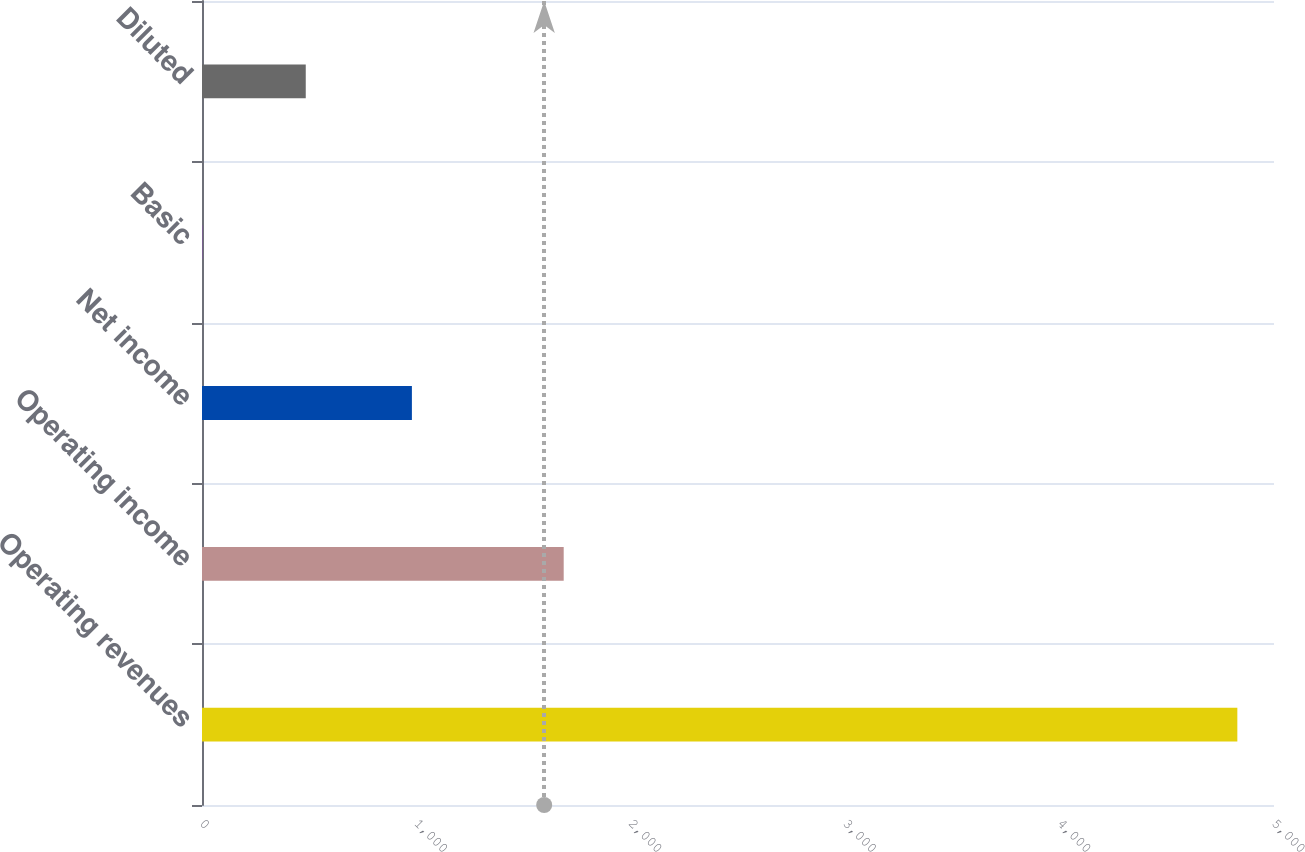<chart> <loc_0><loc_0><loc_500><loc_500><bar_chart><fcel>Operating revenues<fcel>Operating income<fcel>Net income<fcel>Basic<fcel>Diluted<nl><fcel>4829<fcel>1687<fcel>979<fcel>1.16<fcel>483.94<nl></chart> 